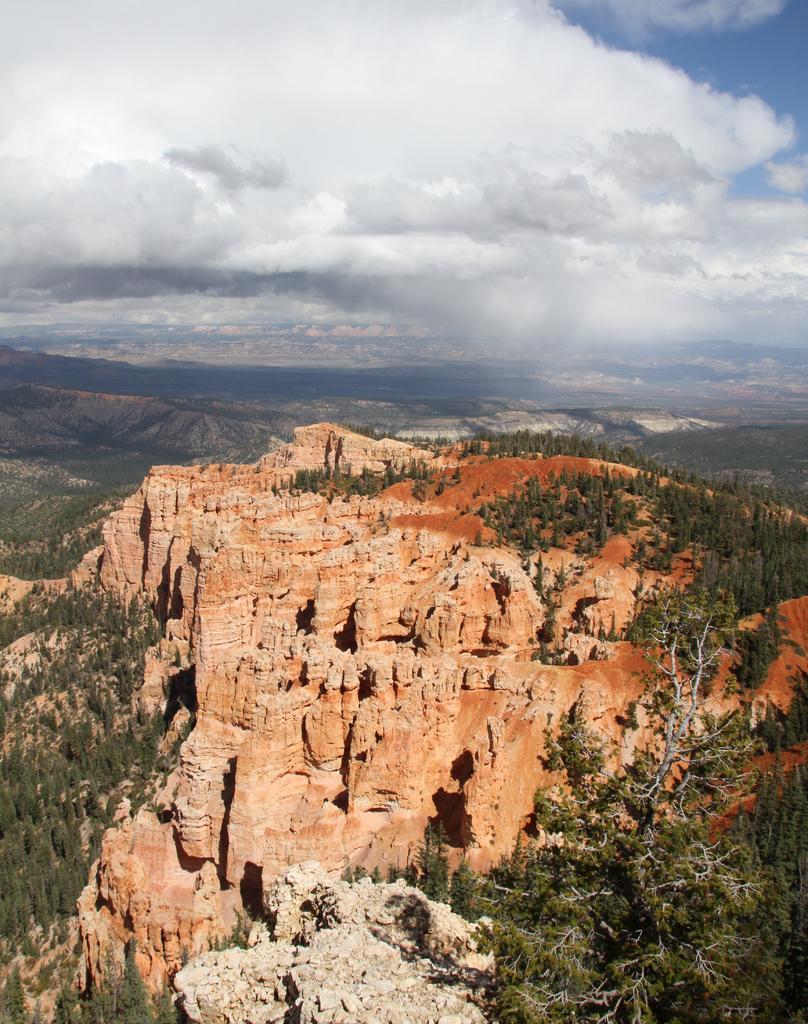Describe this image in one or two sentences. In this image we can see mountains, trees, rock and the sky with clouds at the top. 